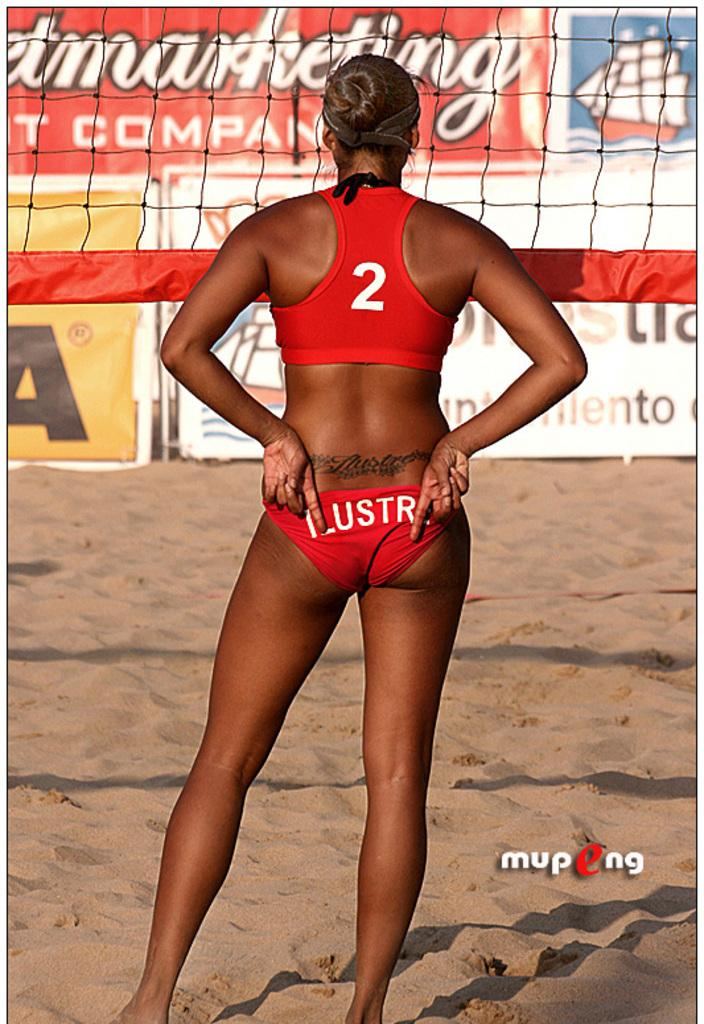<image>
Render a clear and concise summary of the photo. A volleyball player stands in front of the net in a bathing suit that says Lustr on the back. 